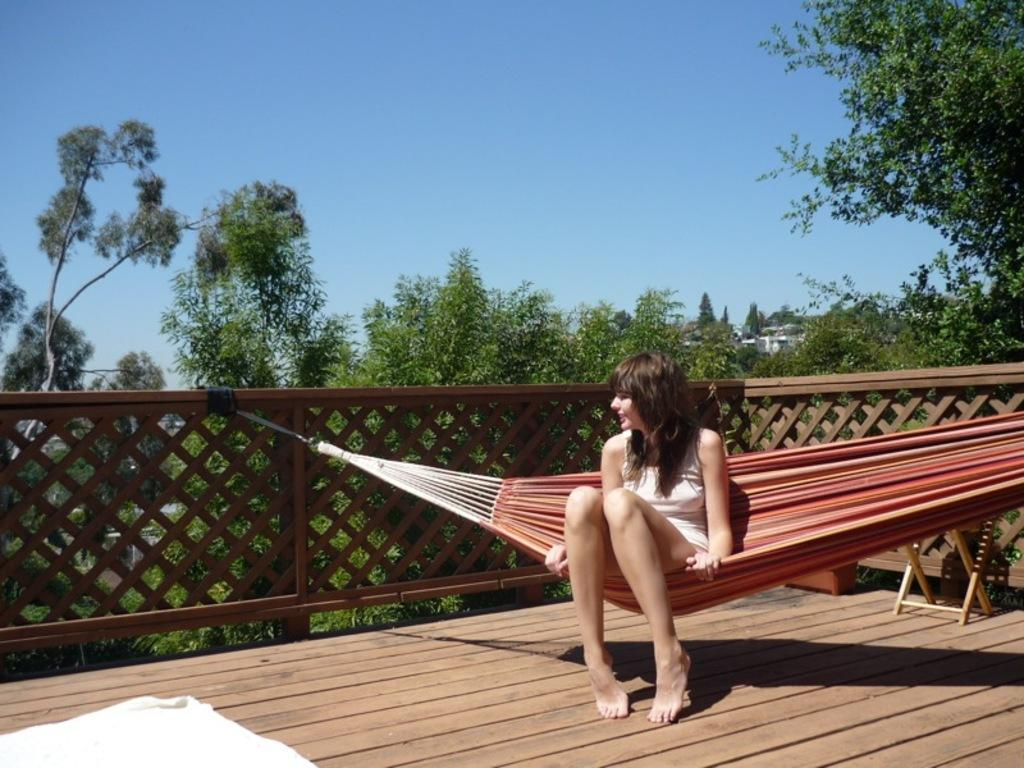Who is the main subject in the image? There is a lady in the image. What is the lady doing in the image? The lady is swinging in a swinging chair. What can be seen in the background of the image? There are trees in the background of the image. What type of fencing is present in the image? There is a wooden fencing in the image. What is visible at the top of the image? The sky is visible at the top of the image. What type of juice is being served in the quicksand in the image? There is no juice or quicksand present in the image; it features a lady swinging in a swinging chair with trees, wooden fencing, and a visible sky in the background. 